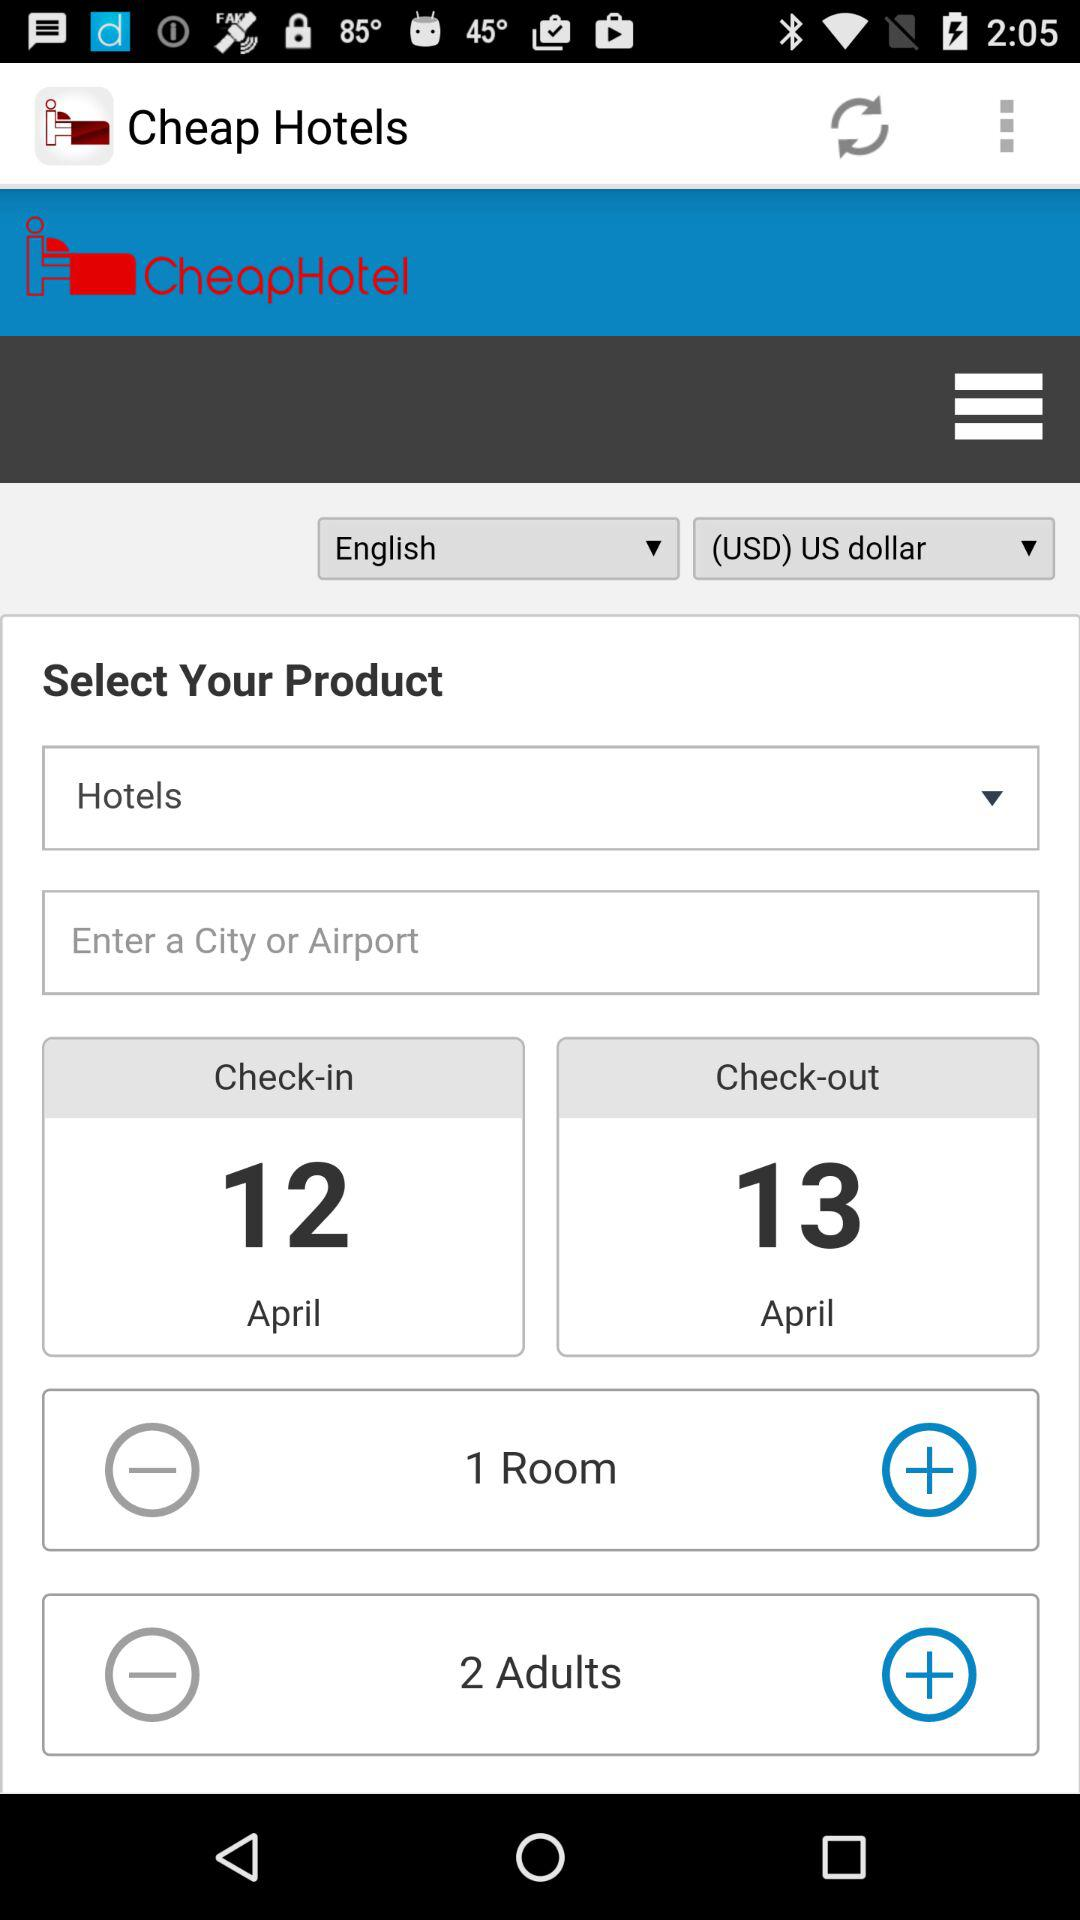How many more adults are there than rooms?
Answer the question using a single word or phrase. 1 